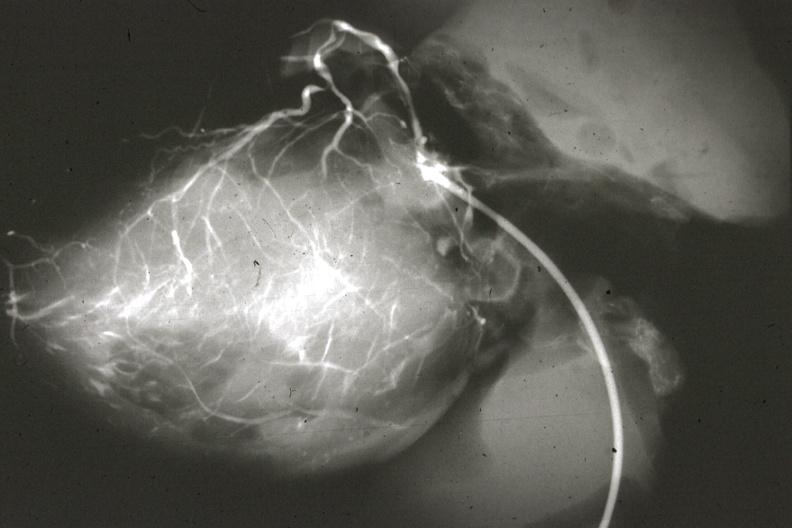what is anomalous origin left?
Answer the question using a single word or phrase. From pulmonary artery 